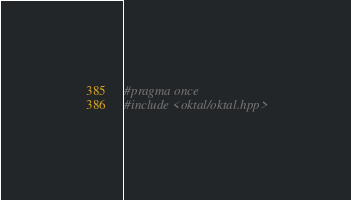<code> <loc_0><loc_0><loc_500><loc_500><_C++_>#pragma once
#include <oktal/oktal.hpp>
</code> 